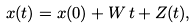<formula> <loc_0><loc_0><loc_500><loc_500>x ( t ) = x ( 0 ) + W \, t + Z ( t ) ,</formula> 